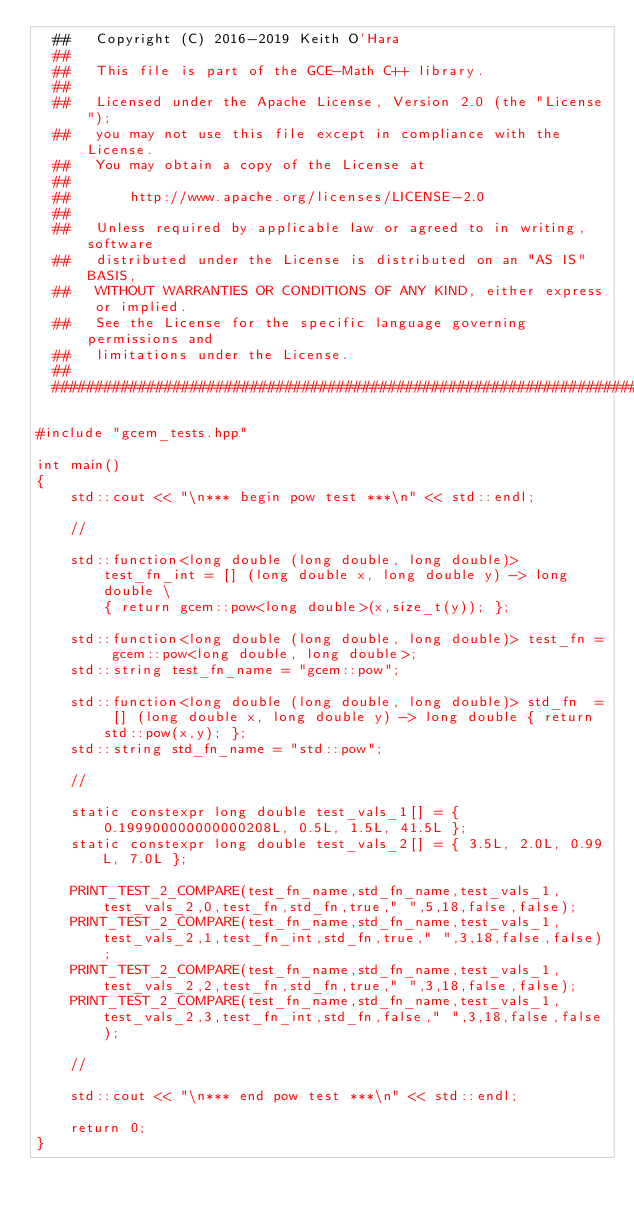<code> <loc_0><loc_0><loc_500><loc_500><_C++_>  ##   Copyright (C) 2016-2019 Keith O'Hara
  ##
  ##   This file is part of the GCE-Math C++ library.
  ##
  ##   Licensed under the Apache License, Version 2.0 (the "License");
  ##   you may not use this file except in compliance with the License.
  ##   You may obtain a copy of the License at
  ##
  ##       http://www.apache.org/licenses/LICENSE-2.0
  ##
  ##   Unless required by applicable law or agreed to in writing, software
  ##   distributed under the License is distributed on an "AS IS" BASIS,
  ##   WITHOUT WARRANTIES OR CONDITIONS OF ANY KIND, either express or implied.
  ##   See the License for the specific language governing permissions and
  ##   limitations under the License.
  ##
  ################################################################################*/

#include "gcem_tests.hpp"

int main()
{
    std::cout << "\n*** begin pow test ***\n" << std::endl;

    //

    std::function<long double (long double, long double)> test_fn_int = [] (long double x, long double y) -> long double \
        { return gcem::pow<long double>(x,size_t(y)); };

    std::function<long double (long double, long double)> test_fn = gcem::pow<long double, long double>;
    std::string test_fn_name = "gcem::pow";

    std::function<long double (long double, long double)> std_fn  = [] (long double x, long double y) -> long double { return std::pow(x,y); };
    std::string std_fn_name = "std::pow";

    //

    static constexpr long double test_vals_1[] = { 0.199900000000000208L, 0.5L, 1.5L, 41.5L };
    static constexpr long double test_vals_2[] = { 3.5L, 2.0L, 0.99L, 7.0L };

    PRINT_TEST_2_COMPARE(test_fn_name,std_fn_name,test_vals_1,test_vals_2,0,test_fn,std_fn,true," ",5,18,false,false);
    PRINT_TEST_2_COMPARE(test_fn_name,std_fn_name,test_vals_1,test_vals_2,1,test_fn_int,std_fn,true," ",3,18,false,false);
    PRINT_TEST_2_COMPARE(test_fn_name,std_fn_name,test_vals_1,test_vals_2,2,test_fn,std_fn,true," ",3,18,false,false);
    PRINT_TEST_2_COMPARE(test_fn_name,std_fn_name,test_vals_1,test_vals_2,3,test_fn_int,std_fn,false," ",3,18,false,false);

    //

    std::cout << "\n*** end pow test ***\n" << std::endl;

    return 0;
}
</code> 